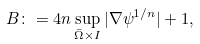<formula> <loc_0><loc_0><loc_500><loc_500>B \colon = 4 n \sup _ { \bar { \Omega } \times I } | \nabla \psi ^ { 1 / n } | + 1 ,</formula> 